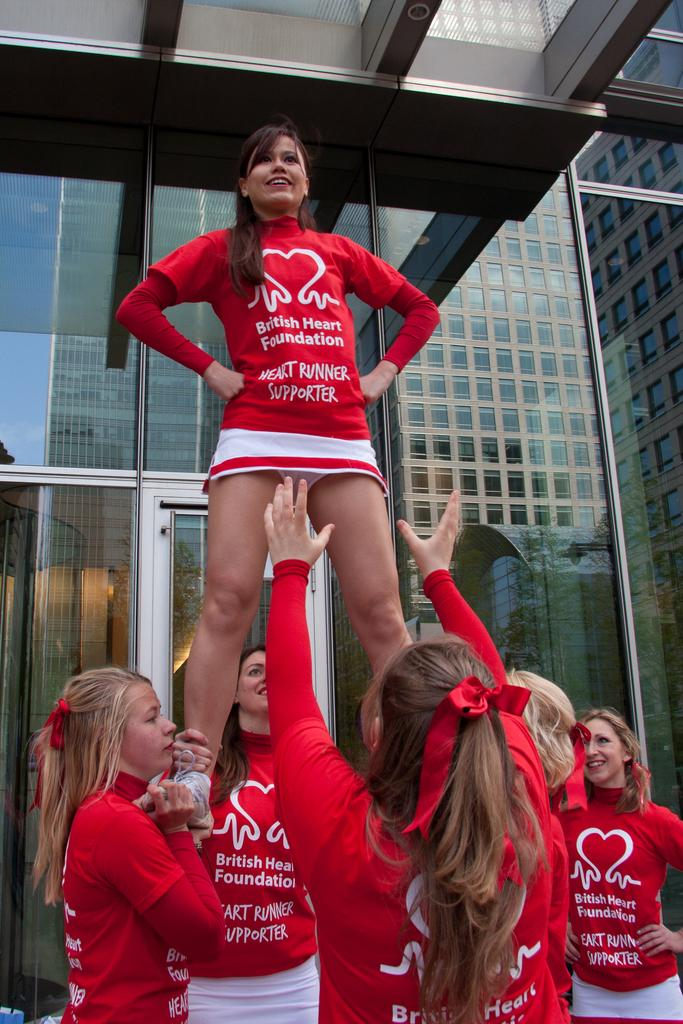<image>
Give a short and clear explanation of the subsequent image. cheerleaders wearing red and white uniforms that are sponsored bt the british heart fondation 